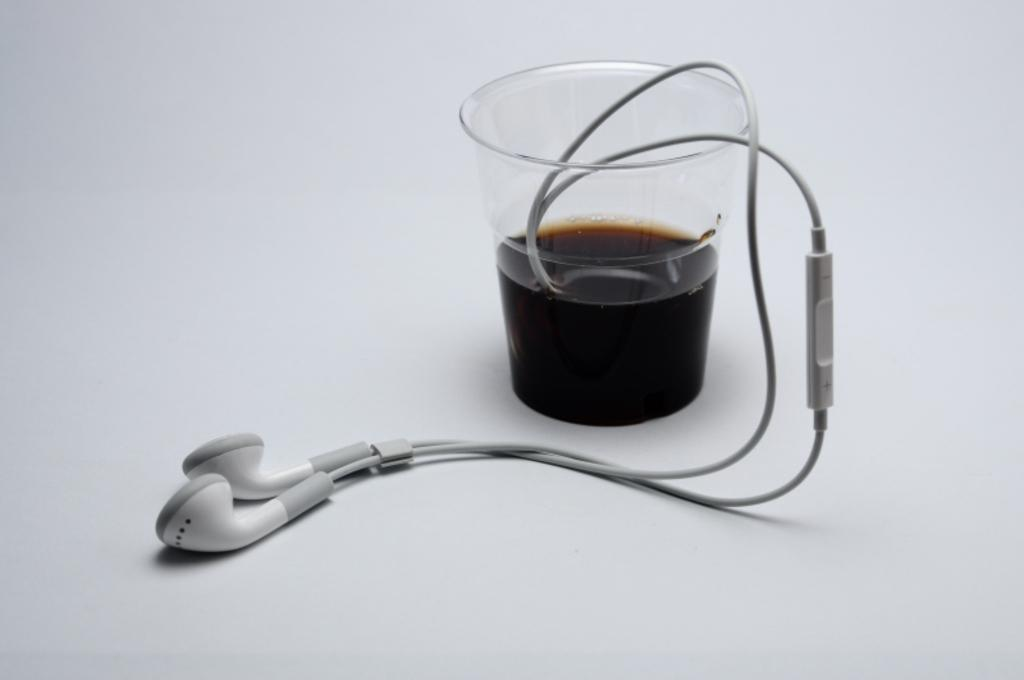What is contained in the glass that is visible in the image? There is a glass of liquid in the image. What type of audio accessory can be seen in the image? Earphones are visible in the image. What color is the surface on which the objects are placed? The objects are on a white surface. How does the paste help in achieving peace in the image? There is no paste or reference to peace in the image; it only features a glass of liquid and earphones on a white surface. 